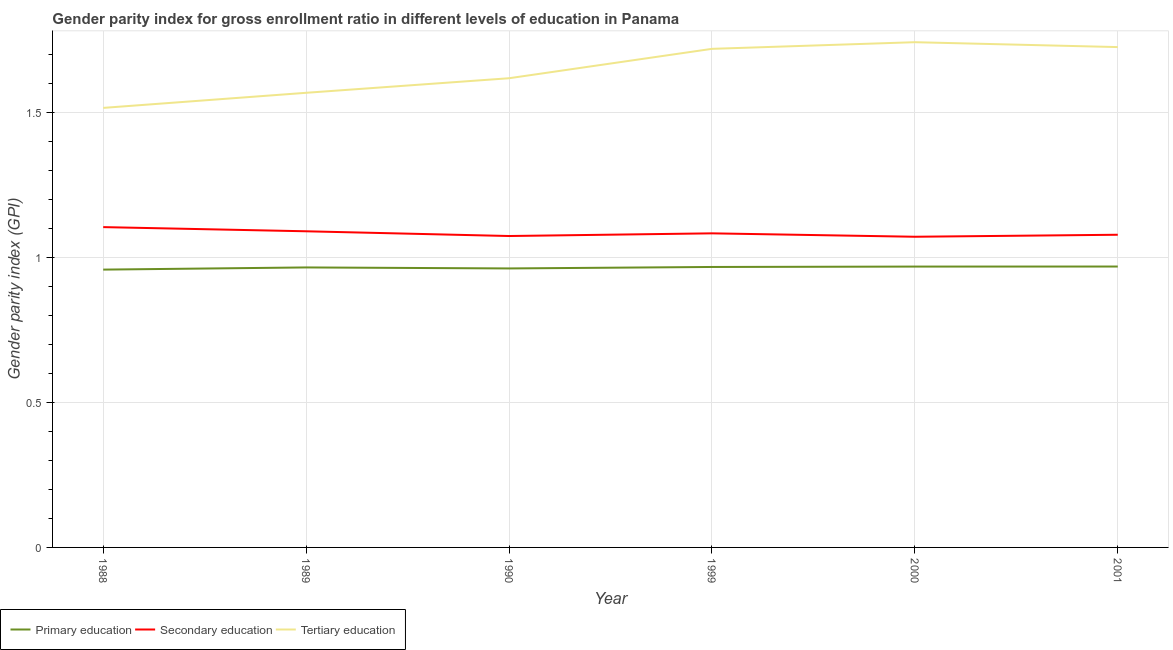How many different coloured lines are there?
Give a very brief answer. 3. What is the gender parity index in secondary education in 1990?
Offer a terse response. 1.07. Across all years, what is the maximum gender parity index in secondary education?
Your answer should be very brief. 1.11. Across all years, what is the minimum gender parity index in tertiary education?
Ensure brevity in your answer.  1.52. In which year was the gender parity index in secondary education maximum?
Make the answer very short. 1988. What is the total gender parity index in tertiary education in the graph?
Keep it short and to the point. 9.89. What is the difference between the gender parity index in tertiary education in 1988 and that in 1999?
Provide a short and direct response. -0.2. What is the difference between the gender parity index in secondary education in 1988 and the gender parity index in tertiary education in 2001?
Provide a short and direct response. -0.62. What is the average gender parity index in secondary education per year?
Keep it short and to the point. 1.08. In the year 1988, what is the difference between the gender parity index in primary education and gender parity index in secondary education?
Give a very brief answer. -0.15. In how many years, is the gender parity index in primary education greater than 1.1?
Ensure brevity in your answer.  0. What is the ratio of the gender parity index in tertiary education in 1988 to that in 1990?
Provide a short and direct response. 0.94. Is the difference between the gender parity index in primary education in 1988 and 1989 greater than the difference between the gender parity index in tertiary education in 1988 and 1989?
Offer a very short reply. Yes. What is the difference between the highest and the second highest gender parity index in primary education?
Offer a very short reply. 0. What is the difference between the highest and the lowest gender parity index in secondary education?
Offer a terse response. 0.03. In how many years, is the gender parity index in tertiary education greater than the average gender parity index in tertiary education taken over all years?
Provide a succinct answer. 3. Is the sum of the gender parity index in primary education in 1988 and 2001 greater than the maximum gender parity index in secondary education across all years?
Provide a succinct answer. Yes. Is it the case that in every year, the sum of the gender parity index in primary education and gender parity index in secondary education is greater than the gender parity index in tertiary education?
Ensure brevity in your answer.  Yes. Does the gender parity index in tertiary education monotonically increase over the years?
Offer a terse response. No. Is the gender parity index in tertiary education strictly greater than the gender parity index in secondary education over the years?
Make the answer very short. Yes. Are the values on the major ticks of Y-axis written in scientific E-notation?
Provide a short and direct response. No. Where does the legend appear in the graph?
Ensure brevity in your answer.  Bottom left. How are the legend labels stacked?
Your answer should be compact. Horizontal. What is the title of the graph?
Make the answer very short. Gender parity index for gross enrollment ratio in different levels of education in Panama. Does "Machinery" appear as one of the legend labels in the graph?
Provide a short and direct response. No. What is the label or title of the X-axis?
Provide a short and direct response. Year. What is the label or title of the Y-axis?
Your response must be concise. Gender parity index (GPI). What is the Gender parity index (GPI) in Primary education in 1988?
Your answer should be very brief. 0.96. What is the Gender parity index (GPI) in Secondary education in 1988?
Offer a terse response. 1.11. What is the Gender parity index (GPI) in Tertiary education in 1988?
Offer a terse response. 1.52. What is the Gender parity index (GPI) in Primary education in 1989?
Provide a succinct answer. 0.97. What is the Gender parity index (GPI) of Secondary education in 1989?
Your response must be concise. 1.09. What is the Gender parity index (GPI) in Tertiary education in 1989?
Your answer should be very brief. 1.57. What is the Gender parity index (GPI) in Primary education in 1990?
Offer a terse response. 0.96. What is the Gender parity index (GPI) in Secondary education in 1990?
Your response must be concise. 1.07. What is the Gender parity index (GPI) in Tertiary education in 1990?
Give a very brief answer. 1.62. What is the Gender parity index (GPI) of Primary education in 1999?
Offer a very short reply. 0.97. What is the Gender parity index (GPI) of Secondary education in 1999?
Your answer should be very brief. 1.08. What is the Gender parity index (GPI) in Tertiary education in 1999?
Offer a very short reply. 1.72. What is the Gender parity index (GPI) of Primary education in 2000?
Ensure brevity in your answer.  0.97. What is the Gender parity index (GPI) of Secondary education in 2000?
Your answer should be compact. 1.07. What is the Gender parity index (GPI) in Tertiary education in 2000?
Ensure brevity in your answer.  1.74. What is the Gender parity index (GPI) in Primary education in 2001?
Your answer should be very brief. 0.97. What is the Gender parity index (GPI) in Secondary education in 2001?
Keep it short and to the point. 1.08. What is the Gender parity index (GPI) in Tertiary education in 2001?
Give a very brief answer. 1.73. Across all years, what is the maximum Gender parity index (GPI) in Primary education?
Keep it short and to the point. 0.97. Across all years, what is the maximum Gender parity index (GPI) of Secondary education?
Keep it short and to the point. 1.11. Across all years, what is the maximum Gender parity index (GPI) of Tertiary education?
Make the answer very short. 1.74. Across all years, what is the minimum Gender parity index (GPI) of Primary education?
Make the answer very short. 0.96. Across all years, what is the minimum Gender parity index (GPI) in Secondary education?
Your response must be concise. 1.07. Across all years, what is the minimum Gender parity index (GPI) of Tertiary education?
Provide a succinct answer. 1.52. What is the total Gender parity index (GPI) of Primary education in the graph?
Provide a succinct answer. 5.79. What is the total Gender parity index (GPI) in Secondary education in the graph?
Your response must be concise. 6.5. What is the total Gender parity index (GPI) in Tertiary education in the graph?
Your response must be concise. 9.89. What is the difference between the Gender parity index (GPI) in Primary education in 1988 and that in 1989?
Provide a short and direct response. -0.01. What is the difference between the Gender parity index (GPI) in Secondary education in 1988 and that in 1989?
Keep it short and to the point. 0.01. What is the difference between the Gender parity index (GPI) of Tertiary education in 1988 and that in 1989?
Offer a very short reply. -0.05. What is the difference between the Gender parity index (GPI) of Primary education in 1988 and that in 1990?
Ensure brevity in your answer.  -0. What is the difference between the Gender parity index (GPI) in Secondary education in 1988 and that in 1990?
Your response must be concise. 0.03. What is the difference between the Gender parity index (GPI) of Tertiary education in 1988 and that in 1990?
Provide a short and direct response. -0.1. What is the difference between the Gender parity index (GPI) of Primary education in 1988 and that in 1999?
Keep it short and to the point. -0.01. What is the difference between the Gender parity index (GPI) of Secondary education in 1988 and that in 1999?
Your response must be concise. 0.02. What is the difference between the Gender parity index (GPI) in Tertiary education in 1988 and that in 1999?
Your answer should be very brief. -0.2. What is the difference between the Gender parity index (GPI) of Primary education in 1988 and that in 2000?
Give a very brief answer. -0.01. What is the difference between the Gender parity index (GPI) in Secondary education in 1988 and that in 2000?
Make the answer very short. 0.03. What is the difference between the Gender parity index (GPI) in Tertiary education in 1988 and that in 2000?
Provide a succinct answer. -0.23. What is the difference between the Gender parity index (GPI) of Primary education in 1988 and that in 2001?
Your response must be concise. -0.01. What is the difference between the Gender parity index (GPI) in Secondary education in 1988 and that in 2001?
Your answer should be very brief. 0.03. What is the difference between the Gender parity index (GPI) of Tertiary education in 1988 and that in 2001?
Your answer should be very brief. -0.21. What is the difference between the Gender parity index (GPI) of Primary education in 1989 and that in 1990?
Your answer should be very brief. 0. What is the difference between the Gender parity index (GPI) in Secondary education in 1989 and that in 1990?
Provide a short and direct response. 0.02. What is the difference between the Gender parity index (GPI) in Tertiary education in 1989 and that in 1990?
Make the answer very short. -0.05. What is the difference between the Gender parity index (GPI) of Primary education in 1989 and that in 1999?
Provide a succinct answer. -0. What is the difference between the Gender parity index (GPI) in Secondary education in 1989 and that in 1999?
Your response must be concise. 0.01. What is the difference between the Gender parity index (GPI) of Tertiary education in 1989 and that in 1999?
Your answer should be compact. -0.15. What is the difference between the Gender parity index (GPI) of Primary education in 1989 and that in 2000?
Provide a succinct answer. -0. What is the difference between the Gender parity index (GPI) in Secondary education in 1989 and that in 2000?
Make the answer very short. 0.02. What is the difference between the Gender parity index (GPI) in Tertiary education in 1989 and that in 2000?
Your response must be concise. -0.17. What is the difference between the Gender parity index (GPI) of Primary education in 1989 and that in 2001?
Give a very brief answer. -0. What is the difference between the Gender parity index (GPI) of Secondary education in 1989 and that in 2001?
Ensure brevity in your answer.  0.01. What is the difference between the Gender parity index (GPI) in Tertiary education in 1989 and that in 2001?
Make the answer very short. -0.16. What is the difference between the Gender parity index (GPI) in Primary education in 1990 and that in 1999?
Provide a succinct answer. -0.01. What is the difference between the Gender parity index (GPI) in Secondary education in 1990 and that in 1999?
Offer a terse response. -0.01. What is the difference between the Gender parity index (GPI) in Tertiary education in 1990 and that in 1999?
Your answer should be very brief. -0.1. What is the difference between the Gender parity index (GPI) of Primary education in 1990 and that in 2000?
Make the answer very short. -0.01. What is the difference between the Gender parity index (GPI) in Secondary education in 1990 and that in 2000?
Your response must be concise. 0. What is the difference between the Gender parity index (GPI) in Tertiary education in 1990 and that in 2000?
Your answer should be compact. -0.12. What is the difference between the Gender parity index (GPI) in Primary education in 1990 and that in 2001?
Keep it short and to the point. -0.01. What is the difference between the Gender parity index (GPI) in Secondary education in 1990 and that in 2001?
Provide a succinct answer. -0. What is the difference between the Gender parity index (GPI) of Tertiary education in 1990 and that in 2001?
Offer a very short reply. -0.11. What is the difference between the Gender parity index (GPI) of Primary education in 1999 and that in 2000?
Your answer should be very brief. -0. What is the difference between the Gender parity index (GPI) in Secondary education in 1999 and that in 2000?
Your answer should be compact. 0.01. What is the difference between the Gender parity index (GPI) of Tertiary education in 1999 and that in 2000?
Offer a terse response. -0.02. What is the difference between the Gender parity index (GPI) of Primary education in 1999 and that in 2001?
Offer a very short reply. -0. What is the difference between the Gender parity index (GPI) of Secondary education in 1999 and that in 2001?
Provide a succinct answer. 0. What is the difference between the Gender parity index (GPI) in Tertiary education in 1999 and that in 2001?
Provide a succinct answer. -0.01. What is the difference between the Gender parity index (GPI) of Primary education in 2000 and that in 2001?
Provide a short and direct response. -0. What is the difference between the Gender parity index (GPI) of Secondary education in 2000 and that in 2001?
Provide a short and direct response. -0.01. What is the difference between the Gender parity index (GPI) in Tertiary education in 2000 and that in 2001?
Keep it short and to the point. 0.02. What is the difference between the Gender parity index (GPI) of Primary education in 1988 and the Gender parity index (GPI) of Secondary education in 1989?
Provide a short and direct response. -0.13. What is the difference between the Gender parity index (GPI) of Primary education in 1988 and the Gender parity index (GPI) of Tertiary education in 1989?
Provide a succinct answer. -0.61. What is the difference between the Gender parity index (GPI) in Secondary education in 1988 and the Gender parity index (GPI) in Tertiary education in 1989?
Provide a short and direct response. -0.46. What is the difference between the Gender parity index (GPI) in Primary education in 1988 and the Gender parity index (GPI) in Secondary education in 1990?
Offer a very short reply. -0.12. What is the difference between the Gender parity index (GPI) of Primary education in 1988 and the Gender parity index (GPI) of Tertiary education in 1990?
Provide a succinct answer. -0.66. What is the difference between the Gender parity index (GPI) of Secondary education in 1988 and the Gender parity index (GPI) of Tertiary education in 1990?
Provide a succinct answer. -0.51. What is the difference between the Gender parity index (GPI) in Primary education in 1988 and the Gender parity index (GPI) in Secondary education in 1999?
Give a very brief answer. -0.13. What is the difference between the Gender parity index (GPI) of Primary education in 1988 and the Gender parity index (GPI) of Tertiary education in 1999?
Provide a short and direct response. -0.76. What is the difference between the Gender parity index (GPI) in Secondary education in 1988 and the Gender parity index (GPI) in Tertiary education in 1999?
Give a very brief answer. -0.61. What is the difference between the Gender parity index (GPI) in Primary education in 1988 and the Gender parity index (GPI) in Secondary education in 2000?
Provide a succinct answer. -0.11. What is the difference between the Gender parity index (GPI) in Primary education in 1988 and the Gender parity index (GPI) in Tertiary education in 2000?
Offer a very short reply. -0.78. What is the difference between the Gender parity index (GPI) of Secondary education in 1988 and the Gender parity index (GPI) of Tertiary education in 2000?
Ensure brevity in your answer.  -0.64. What is the difference between the Gender parity index (GPI) in Primary education in 1988 and the Gender parity index (GPI) in Secondary education in 2001?
Provide a short and direct response. -0.12. What is the difference between the Gender parity index (GPI) of Primary education in 1988 and the Gender parity index (GPI) of Tertiary education in 2001?
Give a very brief answer. -0.77. What is the difference between the Gender parity index (GPI) in Secondary education in 1988 and the Gender parity index (GPI) in Tertiary education in 2001?
Your answer should be compact. -0.62. What is the difference between the Gender parity index (GPI) of Primary education in 1989 and the Gender parity index (GPI) of Secondary education in 1990?
Offer a very short reply. -0.11. What is the difference between the Gender parity index (GPI) of Primary education in 1989 and the Gender parity index (GPI) of Tertiary education in 1990?
Make the answer very short. -0.65. What is the difference between the Gender parity index (GPI) of Secondary education in 1989 and the Gender parity index (GPI) of Tertiary education in 1990?
Give a very brief answer. -0.53. What is the difference between the Gender parity index (GPI) of Primary education in 1989 and the Gender parity index (GPI) of Secondary education in 1999?
Offer a very short reply. -0.12. What is the difference between the Gender parity index (GPI) in Primary education in 1989 and the Gender parity index (GPI) in Tertiary education in 1999?
Ensure brevity in your answer.  -0.75. What is the difference between the Gender parity index (GPI) in Secondary education in 1989 and the Gender parity index (GPI) in Tertiary education in 1999?
Offer a terse response. -0.63. What is the difference between the Gender parity index (GPI) in Primary education in 1989 and the Gender parity index (GPI) in Secondary education in 2000?
Give a very brief answer. -0.11. What is the difference between the Gender parity index (GPI) of Primary education in 1989 and the Gender parity index (GPI) of Tertiary education in 2000?
Your answer should be very brief. -0.78. What is the difference between the Gender parity index (GPI) of Secondary education in 1989 and the Gender parity index (GPI) of Tertiary education in 2000?
Your response must be concise. -0.65. What is the difference between the Gender parity index (GPI) in Primary education in 1989 and the Gender parity index (GPI) in Secondary education in 2001?
Your response must be concise. -0.11. What is the difference between the Gender parity index (GPI) of Primary education in 1989 and the Gender parity index (GPI) of Tertiary education in 2001?
Offer a terse response. -0.76. What is the difference between the Gender parity index (GPI) in Secondary education in 1989 and the Gender parity index (GPI) in Tertiary education in 2001?
Provide a short and direct response. -0.64. What is the difference between the Gender parity index (GPI) of Primary education in 1990 and the Gender parity index (GPI) of Secondary education in 1999?
Give a very brief answer. -0.12. What is the difference between the Gender parity index (GPI) in Primary education in 1990 and the Gender parity index (GPI) in Tertiary education in 1999?
Provide a short and direct response. -0.76. What is the difference between the Gender parity index (GPI) in Secondary education in 1990 and the Gender parity index (GPI) in Tertiary education in 1999?
Give a very brief answer. -0.65. What is the difference between the Gender parity index (GPI) of Primary education in 1990 and the Gender parity index (GPI) of Secondary education in 2000?
Ensure brevity in your answer.  -0.11. What is the difference between the Gender parity index (GPI) of Primary education in 1990 and the Gender parity index (GPI) of Tertiary education in 2000?
Provide a succinct answer. -0.78. What is the difference between the Gender parity index (GPI) of Secondary education in 1990 and the Gender parity index (GPI) of Tertiary education in 2000?
Provide a short and direct response. -0.67. What is the difference between the Gender parity index (GPI) of Primary education in 1990 and the Gender parity index (GPI) of Secondary education in 2001?
Offer a very short reply. -0.12. What is the difference between the Gender parity index (GPI) in Primary education in 1990 and the Gender parity index (GPI) in Tertiary education in 2001?
Your answer should be very brief. -0.76. What is the difference between the Gender parity index (GPI) of Secondary education in 1990 and the Gender parity index (GPI) of Tertiary education in 2001?
Make the answer very short. -0.65. What is the difference between the Gender parity index (GPI) in Primary education in 1999 and the Gender parity index (GPI) in Secondary education in 2000?
Provide a succinct answer. -0.1. What is the difference between the Gender parity index (GPI) of Primary education in 1999 and the Gender parity index (GPI) of Tertiary education in 2000?
Keep it short and to the point. -0.78. What is the difference between the Gender parity index (GPI) in Secondary education in 1999 and the Gender parity index (GPI) in Tertiary education in 2000?
Keep it short and to the point. -0.66. What is the difference between the Gender parity index (GPI) in Primary education in 1999 and the Gender parity index (GPI) in Secondary education in 2001?
Your answer should be compact. -0.11. What is the difference between the Gender parity index (GPI) of Primary education in 1999 and the Gender parity index (GPI) of Tertiary education in 2001?
Your response must be concise. -0.76. What is the difference between the Gender parity index (GPI) of Secondary education in 1999 and the Gender parity index (GPI) of Tertiary education in 2001?
Provide a short and direct response. -0.64. What is the difference between the Gender parity index (GPI) of Primary education in 2000 and the Gender parity index (GPI) of Secondary education in 2001?
Give a very brief answer. -0.11. What is the difference between the Gender parity index (GPI) of Primary education in 2000 and the Gender parity index (GPI) of Tertiary education in 2001?
Offer a terse response. -0.76. What is the difference between the Gender parity index (GPI) in Secondary education in 2000 and the Gender parity index (GPI) in Tertiary education in 2001?
Offer a terse response. -0.65. What is the average Gender parity index (GPI) of Primary education per year?
Your answer should be compact. 0.97. What is the average Gender parity index (GPI) of Secondary education per year?
Your answer should be very brief. 1.08. What is the average Gender parity index (GPI) in Tertiary education per year?
Your answer should be compact. 1.65. In the year 1988, what is the difference between the Gender parity index (GPI) in Primary education and Gender parity index (GPI) in Secondary education?
Keep it short and to the point. -0.15. In the year 1988, what is the difference between the Gender parity index (GPI) of Primary education and Gender parity index (GPI) of Tertiary education?
Ensure brevity in your answer.  -0.56. In the year 1988, what is the difference between the Gender parity index (GPI) in Secondary education and Gender parity index (GPI) in Tertiary education?
Keep it short and to the point. -0.41. In the year 1989, what is the difference between the Gender parity index (GPI) of Primary education and Gender parity index (GPI) of Secondary education?
Ensure brevity in your answer.  -0.12. In the year 1989, what is the difference between the Gender parity index (GPI) of Primary education and Gender parity index (GPI) of Tertiary education?
Offer a very short reply. -0.6. In the year 1989, what is the difference between the Gender parity index (GPI) of Secondary education and Gender parity index (GPI) of Tertiary education?
Give a very brief answer. -0.48. In the year 1990, what is the difference between the Gender parity index (GPI) of Primary education and Gender parity index (GPI) of Secondary education?
Your answer should be compact. -0.11. In the year 1990, what is the difference between the Gender parity index (GPI) in Primary education and Gender parity index (GPI) in Tertiary education?
Provide a short and direct response. -0.66. In the year 1990, what is the difference between the Gender parity index (GPI) of Secondary education and Gender parity index (GPI) of Tertiary education?
Offer a terse response. -0.54. In the year 1999, what is the difference between the Gender parity index (GPI) in Primary education and Gender parity index (GPI) in Secondary education?
Your answer should be very brief. -0.12. In the year 1999, what is the difference between the Gender parity index (GPI) in Primary education and Gender parity index (GPI) in Tertiary education?
Give a very brief answer. -0.75. In the year 1999, what is the difference between the Gender parity index (GPI) of Secondary education and Gender parity index (GPI) of Tertiary education?
Your answer should be compact. -0.64. In the year 2000, what is the difference between the Gender parity index (GPI) of Primary education and Gender parity index (GPI) of Secondary education?
Provide a succinct answer. -0.1. In the year 2000, what is the difference between the Gender parity index (GPI) of Primary education and Gender parity index (GPI) of Tertiary education?
Offer a very short reply. -0.77. In the year 2000, what is the difference between the Gender parity index (GPI) of Secondary education and Gender parity index (GPI) of Tertiary education?
Ensure brevity in your answer.  -0.67. In the year 2001, what is the difference between the Gender parity index (GPI) in Primary education and Gender parity index (GPI) in Secondary education?
Make the answer very short. -0.11. In the year 2001, what is the difference between the Gender parity index (GPI) of Primary education and Gender parity index (GPI) of Tertiary education?
Your response must be concise. -0.76. In the year 2001, what is the difference between the Gender parity index (GPI) of Secondary education and Gender parity index (GPI) of Tertiary education?
Your answer should be very brief. -0.65. What is the ratio of the Gender parity index (GPI) in Primary education in 1988 to that in 1989?
Offer a very short reply. 0.99. What is the ratio of the Gender parity index (GPI) of Secondary education in 1988 to that in 1989?
Your answer should be very brief. 1.01. What is the ratio of the Gender parity index (GPI) in Tertiary education in 1988 to that in 1989?
Keep it short and to the point. 0.97. What is the ratio of the Gender parity index (GPI) in Primary education in 1988 to that in 1990?
Give a very brief answer. 1. What is the ratio of the Gender parity index (GPI) in Secondary education in 1988 to that in 1990?
Make the answer very short. 1.03. What is the ratio of the Gender parity index (GPI) in Tertiary education in 1988 to that in 1990?
Give a very brief answer. 0.94. What is the ratio of the Gender parity index (GPI) of Primary education in 1988 to that in 1999?
Make the answer very short. 0.99. What is the ratio of the Gender parity index (GPI) in Secondary education in 1988 to that in 1999?
Ensure brevity in your answer.  1.02. What is the ratio of the Gender parity index (GPI) in Tertiary education in 1988 to that in 1999?
Give a very brief answer. 0.88. What is the ratio of the Gender parity index (GPI) of Primary education in 1988 to that in 2000?
Your response must be concise. 0.99. What is the ratio of the Gender parity index (GPI) in Secondary education in 1988 to that in 2000?
Offer a terse response. 1.03. What is the ratio of the Gender parity index (GPI) in Tertiary education in 1988 to that in 2000?
Your answer should be compact. 0.87. What is the ratio of the Gender parity index (GPI) of Secondary education in 1988 to that in 2001?
Provide a short and direct response. 1.02. What is the ratio of the Gender parity index (GPI) of Tertiary education in 1988 to that in 2001?
Provide a succinct answer. 0.88. What is the ratio of the Gender parity index (GPI) of Primary education in 1989 to that in 1990?
Provide a short and direct response. 1. What is the ratio of the Gender parity index (GPI) of Secondary education in 1989 to that in 1990?
Your response must be concise. 1.02. What is the ratio of the Gender parity index (GPI) in Primary education in 1989 to that in 1999?
Keep it short and to the point. 1. What is the ratio of the Gender parity index (GPI) in Secondary education in 1989 to that in 1999?
Keep it short and to the point. 1.01. What is the ratio of the Gender parity index (GPI) in Tertiary education in 1989 to that in 1999?
Your response must be concise. 0.91. What is the ratio of the Gender parity index (GPI) of Secondary education in 1989 to that in 2000?
Your answer should be compact. 1.02. What is the ratio of the Gender parity index (GPI) in Tertiary education in 1989 to that in 2000?
Keep it short and to the point. 0.9. What is the ratio of the Gender parity index (GPI) in Secondary education in 1989 to that in 2001?
Your answer should be very brief. 1.01. What is the ratio of the Gender parity index (GPI) of Tertiary education in 1989 to that in 2001?
Ensure brevity in your answer.  0.91. What is the ratio of the Gender parity index (GPI) of Secondary education in 1990 to that in 1999?
Keep it short and to the point. 0.99. What is the ratio of the Gender parity index (GPI) of Tertiary education in 1990 to that in 1999?
Give a very brief answer. 0.94. What is the ratio of the Gender parity index (GPI) of Secondary education in 1990 to that in 2000?
Your answer should be compact. 1. What is the ratio of the Gender parity index (GPI) of Tertiary education in 1990 to that in 2000?
Ensure brevity in your answer.  0.93. What is the ratio of the Gender parity index (GPI) in Primary education in 1990 to that in 2001?
Ensure brevity in your answer.  0.99. What is the ratio of the Gender parity index (GPI) of Secondary education in 1990 to that in 2001?
Provide a succinct answer. 1. What is the ratio of the Gender parity index (GPI) of Tertiary education in 1990 to that in 2001?
Your answer should be very brief. 0.94. What is the ratio of the Gender parity index (GPI) of Primary education in 1999 to that in 2000?
Ensure brevity in your answer.  1. What is the ratio of the Gender parity index (GPI) in Tertiary education in 1999 to that in 2000?
Ensure brevity in your answer.  0.99. What is the ratio of the Gender parity index (GPI) in Tertiary education in 1999 to that in 2001?
Offer a terse response. 1. What is the ratio of the Gender parity index (GPI) in Tertiary education in 2000 to that in 2001?
Offer a very short reply. 1.01. What is the difference between the highest and the second highest Gender parity index (GPI) in Primary education?
Your answer should be very brief. 0. What is the difference between the highest and the second highest Gender parity index (GPI) of Secondary education?
Offer a very short reply. 0.01. What is the difference between the highest and the second highest Gender parity index (GPI) of Tertiary education?
Your answer should be compact. 0.02. What is the difference between the highest and the lowest Gender parity index (GPI) of Primary education?
Give a very brief answer. 0.01. What is the difference between the highest and the lowest Gender parity index (GPI) in Tertiary education?
Offer a terse response. 0.23. 